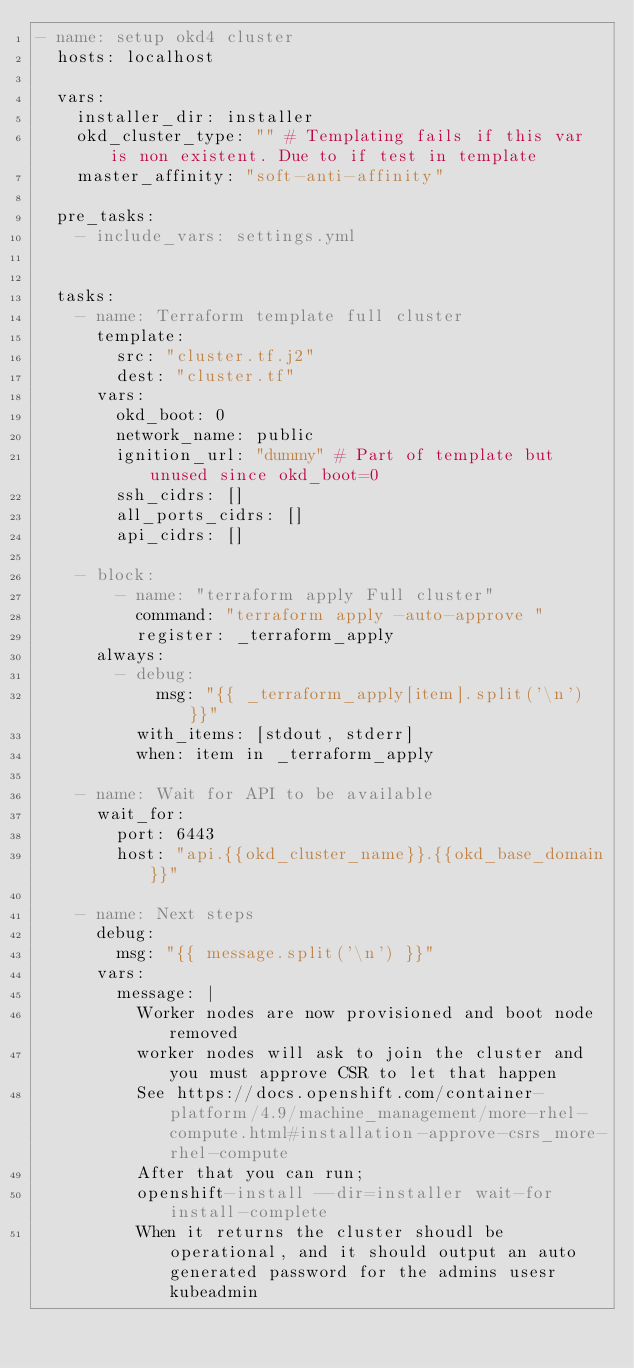Convert code to text. <code><loc_0><loc_0><loc_500><loc_500><_YAML_>- name: setup okd4 cluster
  hosts: localhost

  vars:
    installer_dir: installer
    okd_cluster_type: "" # Templating fails if this var is non existent. Due to if test in template
    master_affinity: "soft-anti-affinity"

  pre_tasks:
    - include_vars: settings.yml


  tasks:
    - name: Terraform template full cluster
      template:
        src: "cluster.tf.j2"
        dest: "cluster.tf"
      vars:
        okd_boot: 0
        network_name: public
        ignition_url: "dummy" # Part of template but unused since okd_boot=0
        ssh_cidrs: []
        all_ports_cidrs: []
        api_cidrs: []

    - block:
        - name: "terraform apply Full cluster"
          command: "terraform apply -auto-approve "
          register: _terraform_apply
      always:
        - debug:
            msg: "{{ _terraform_apply[item].split('\n') }}"
          with_items: [stdout, stderr]
          when: item in _terraform_apply

    - name: Wait for API to be available
      wait_for:
        port: 6443
        host: "api.{{okd_cluster_name}}.{{okd_base_domain}}"

    - name: Next steps
      debug:
        msg: "{{ message.split('\n') }}"
      vars:
        message: |
          Worker nodes are now provisioned and boot node removed
          worker nodes will ask to join the cluster and you must approve CSR to let that happen
          See https://docs.openshift.com/container-platform/4.9/machine_management/more-rhel-compute.html#installation-approve-csrs_more-rhel-compute
          After that you can run;
          openshift-install --dir=installer wait-for install-complete
          When it returns the cluster shoudl be operational, and it should output an auto generated password for the admins usesr kubeadmin
</code> 